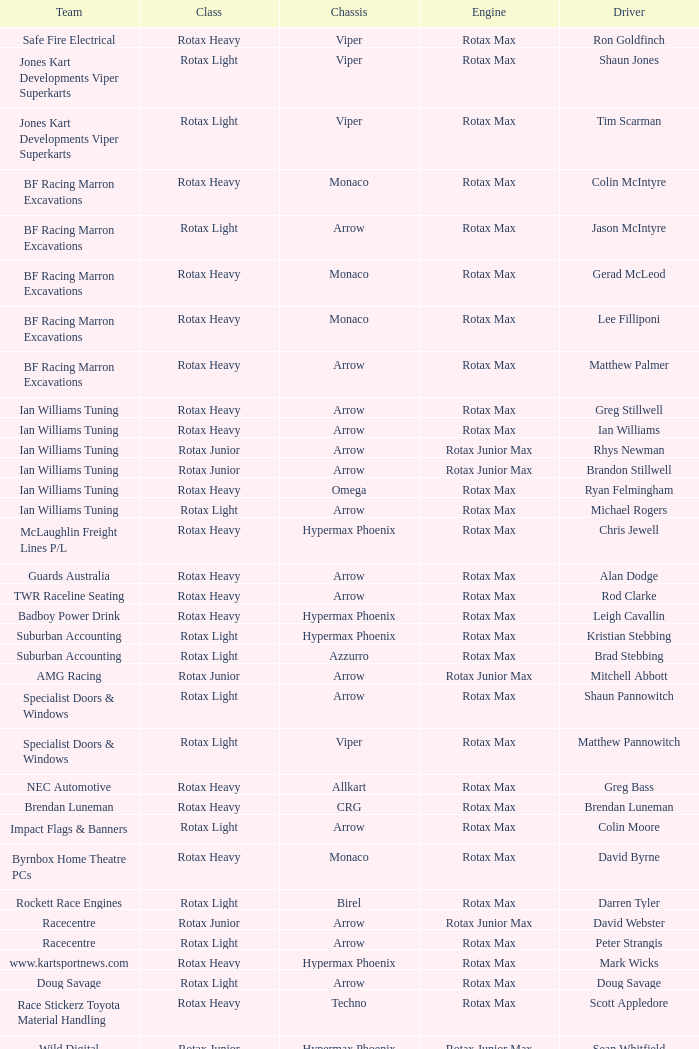What is the name of the team that falls under the rotax light division? Jones Kart Developments Viper Superkarts, Jones Kart Developments Viper Superkarts, BF Racing Marron Excavations, Ian Williams Tuning, Suburban Accounting, Suburban Accounting, Specialist Doors & Windows, Specialist Doors & Windows, Impact Flags & Banners, Rockett Race Engines, Racecentre, Doug Savage. 